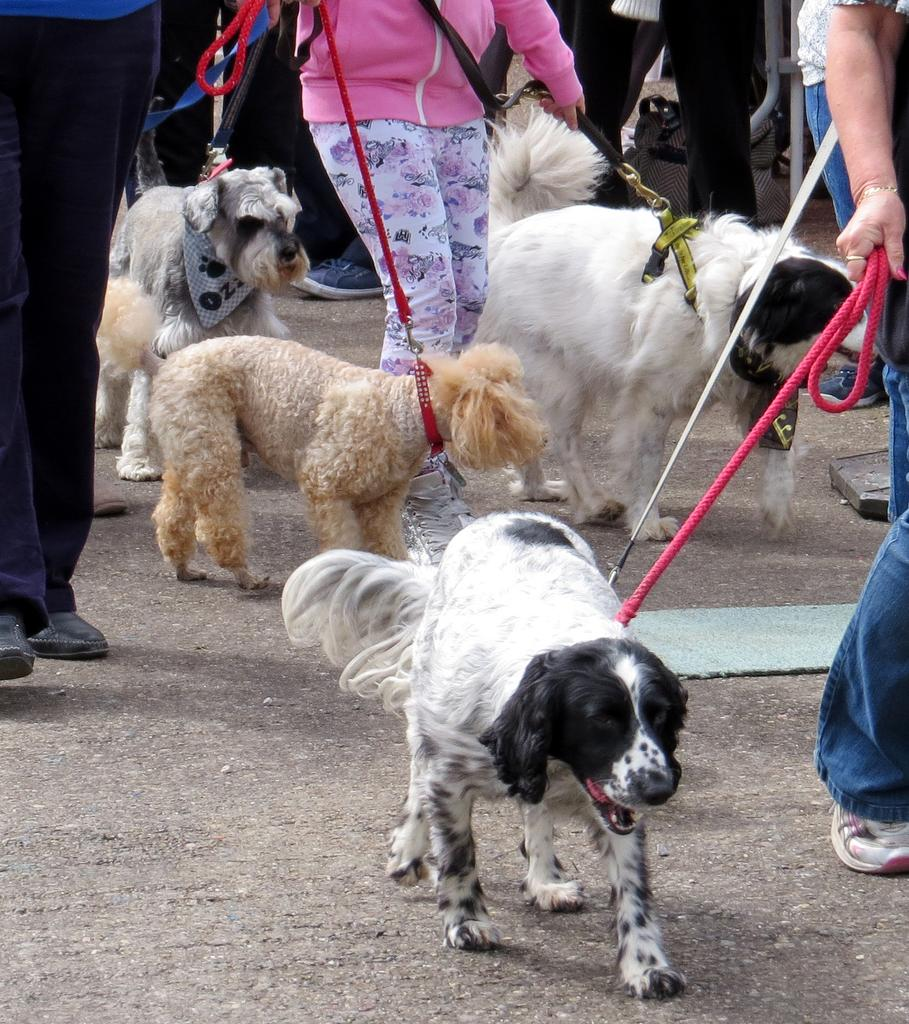Who or what is present in the image? There are people in the image. What are the people holding in the image? The people are holding belts in the image. What are the belts connected to? The belts are tied to dogs in the image. What type of kite is being flown by the people in the image? There is no kite present in the image. What kind of fowl can be seen interacting with the people in the image? There is no fowl present in the image; the people are holding belts tied to dogs. 